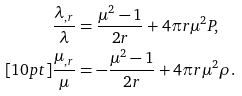Convert formula to latex. <formula><loc_0><loc_0><loc_500><loc_500>\frac { \lambda _ { , r } } { \lambda } & = \frac { \mu ^ { 2 } - 1 } { 2 r } + 4 \pi r \mu ^ { 2 } P , \\ [ 1 0 p t ] \frac { \mu _ { , r } } { \mu } & = - \frac { \mu ^ { 2 } - 1 } { 2 r } + 4 \pi r \mu ^ { 2 } \rho .</formula> 